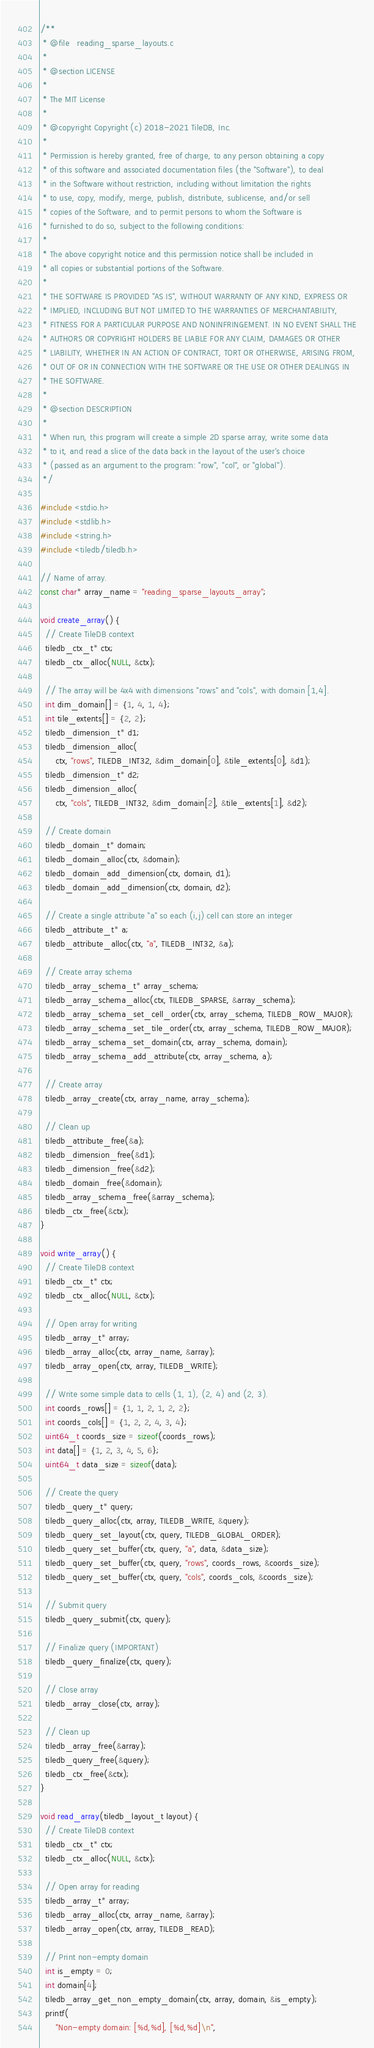Convert code to text. <code><loc_0><loc_0><loc_500><loc_500><_C_>/**
 * @file   reading_sparse_layouts.c
 *
 * @section LICENSE
 *
 * The MIT License
 *
 * @copyright Copyright (c) 2018-2021 TileDB, Inc.
 *
 * Permission is hereby granted, free of charge, to any person obtaining a copy
 * of this software and associated documentation files (the "Software"), to deal
 * in the Software without restriction, including without limitation the rights
 * to use, copy, modify, merge, publish, distribute, sublicense, and/or sell
 * copies of the Software, and to permit persons to whom the Software is
 * furnished to do so, subject to the following conditions:
 *
 * The above copyright notice and this permission notice shall be included in
 * all copies or substantial portions of the Software.
 *
 * THE SOFTWARE IS PROVIDED "AS IS", WITHOUT WARRANTY OF ANY KIND, EXPRESS OR
 * IMPLIED, INCLUDING BUT NOT LIMITED TO THE WARRANTIES OF MERCHANTABILITY,
 * FITNESS FOR A PARTICULAR PURPOSE AND NONINFRINGEMENT. IN NO EVENT SHALL THE
 * AUTHORS OR COPYRIGHT HOLDERS BE LIABLE FOR ANY CLAIM, DAMAGES OR OTHER
 * LIABILITY, WHETHER IN AN ACTION OF CONTRACT, TORT OR OTHERWISE, ARISING FROM,
 * OUT OF OR IN CONNECTION WITH THE SOFTWARE OR THE USE OR OTHER DEALINGS IN
 * THE SOFTWARE.
 *
 * @section DESCRIPTION
 *
 * When run, this program will create a simple 2D sparse array, write some data
 * to it, and read a slice of the data back in the layout of the user's choice
 * (passed as an argument to the program: "row", "col", or "global").
 */

#include <stdio.h>
#include <stdlib.h>
#include <string.h>
#include <tiledb/tiledb.h>

// Name of array.
const char* array_name = "reading_sparse_layouts_array";

void create_array() {
  // Create TileDB context
  tiledb_ctx_t* ctx;
  tiledb_ctx_alloc(NULL, &ctx);

  // The array will be 4x4 with dimensions "rows" and "cols", with domain [1,4].
  int dim_domain[] = {1, 4, 1, 4};
  int tile_extents[] = {2, 2};
  tiledb_dimension_t* d1;
  tiledb_dimension_alloc(
      ctx, "rows", TILEDB_INT32, &dim_domain[0], &tile_extents[0], &d1);
  tiledb_dimension_t* d2;
  tiledb_dimension_alloc(
      ctx, "cols", TILEDB_INT32, &dim_domain[2], &tile_extents[1], &d2);

  // Create domain
  tiledb_domain_t* domain;
  tiledb_domain_alloc(ctx, &domain);
  tiledb_domain_add_dimension(ctx, domain, d1);
  tiledb_domain_add_dimension(ctx, domain, d2);

  // Create a single attribute "a" so each (i,j) cell can store an integer
  tiledb_attribute_t* a;
  tiledb_attribute_alloc(ctx, "a", TILEDB_INT32, &a);

  // Create array schema
  tiledb_array_schema_t* array_schema;
  tiledb_array_schema_alloc(ctx, TILEDB_SPARSE, &array_schema);
  tiledb_array_schema_set_cell_order(ctx, array_schema, TILEDB_ROW_MAJOR);
  tiledb_array_schema_set_tile_order(ctx, array_schema, TILEDB_ROW_MAJOR);
  tiledb_array_schema_set_domain(ctx, array_schema, domain);
  tiledb_array_schema_add_attribute(ctx, array_schema, a);

  // Create array
  tiledb_array_create(ctx, array_name, array_schema);

  // Clean up
  tiledb_attribute_free(&a);
  tiledb_dimension_free(&d1);
  tiledb_dimension_free(&d2);
  tiledb_domain_free(&domain);
  tiledb_array_schema_free(&array_schema);
  tiledb_ctx_free(&ctx);
}

void write_array() {
  // Create TileDB context
  tiledb_ctx_t* ctx;
  tiledb_ctx_alloc(NULL, &ctx);

  // Open array for writing
  tiledb_array_t* array;
  tiledb_array_alloc(ctx, array_name, &array);
  tiledb_array_open(ctx, array, TILEDB_WRITE);

  // Write some simple data to cells (1, 1), (2, 4) and (2, 3).
  int coords_rows[] = {1, 1, 2, 1, 2, 2};
  int coords_cols[] = {1, 2, 2, 4, 3, 4};
  uint64_t coords_size = sizeof(coords_rows);
  int data[] = {1, 2, 3, 4, 5, 6};
  uint64_t data_size = sizeof(data);

  // Create the query
  tiledb_query_t* query;
  tiledb_query_alloc(ctx, array, TILEDB_WRITE, &query);
  tiledb_query_set_layout(ctx, query, TILEDB_GLOBAL_ORDER);
  tiledb_query_set_buffer(ctx, query, "a", data, &data_size);
  tiledb_query_set_buffer(ctx, query, "rows", coords_rows, &coords_size);
  tiledb_query_set_buffer(ctx, query, "cols", coords_cols, &coords_size);

  // Submit query
  tiledb_query_submit(ctx, query);

  // Finalize query (IMPORTANT)
  tiledb_query_finalize(ctx, query);

  // Close array
  tiledb_array_close(ctx, array);

  // Clean up
  tiledb_array_free(&array);
  tiledb_query_free(&query);
  tiledb_ctx_free(&ctx);
}

void read_array(tiledb_layout_t layout) {
  // Create TileDB context
  tiledb_ctx_t* ctx;
  tiledb_ctx_alloc(NULL, &ctx);

  // Open array for reading
  tiledb_array_t* array;
  tiledb_array_alloc(ctx, array_name, &array);
  tiledb_array_open(ctx, array, TILEDB_READ);

  // Print non-empty domain
  int is_empty = 0;
  int domain[4];
  tiledb_array_get_non_empty_domain(ctx, array, domain, &is_empty);
  printf(
      "Non-empty domain: [%d,%d], [%d,%d]\n",</code> 